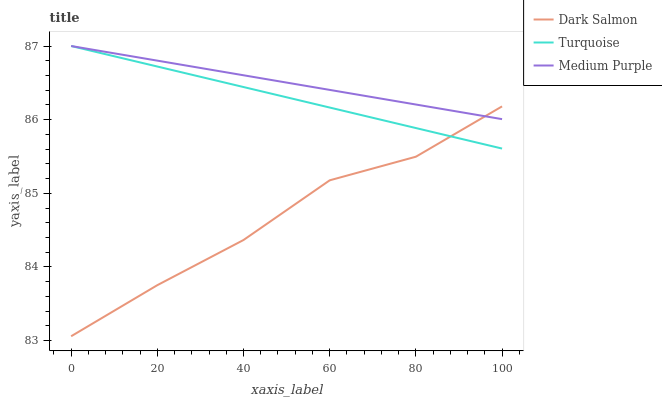Does Dark Salmon have the minimum area under the curve?
Answer yes or no. Yes. Does Medium Purple have the maximum area under the curve?
Answer yes or no. Yes. Does Turquoise have the minimum area under the curve?
Answer yes or no. No. Does Turquoise have the maximum area under the curve?
Answer yes or no. No. Is Turquoise the smoothest?
Answer yes or no. Yes. Is Dark Salmon the roughest?
Answer yes or no. Yes. Is Dark Salmon the smoothest?
Answer yes or no. No. Is Turquoise the roughest?
Answer yes or no. No. Does Dark Salmon have the lowest value?
Answer yes or no. Yes. Does Turquoise have the lowest value?
Answer yes or no. No. Does Turquoise have the highest value?
Answer yes or no. Yes. Does Dark Salmon have the highest value?
Answer yes or no. No. Does Dark Salmon intersect Turquoise?
Answer yes or no. Yes. Is Dark Salmon less than Turquoise?
Answer yes or no. No. Is Dark Salmon greater than Turquoise?
Answer yes or no. No. 